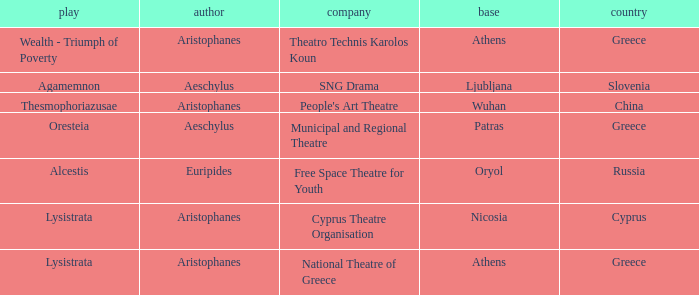What is the company when the base is ljubljana? SNG Drama. 